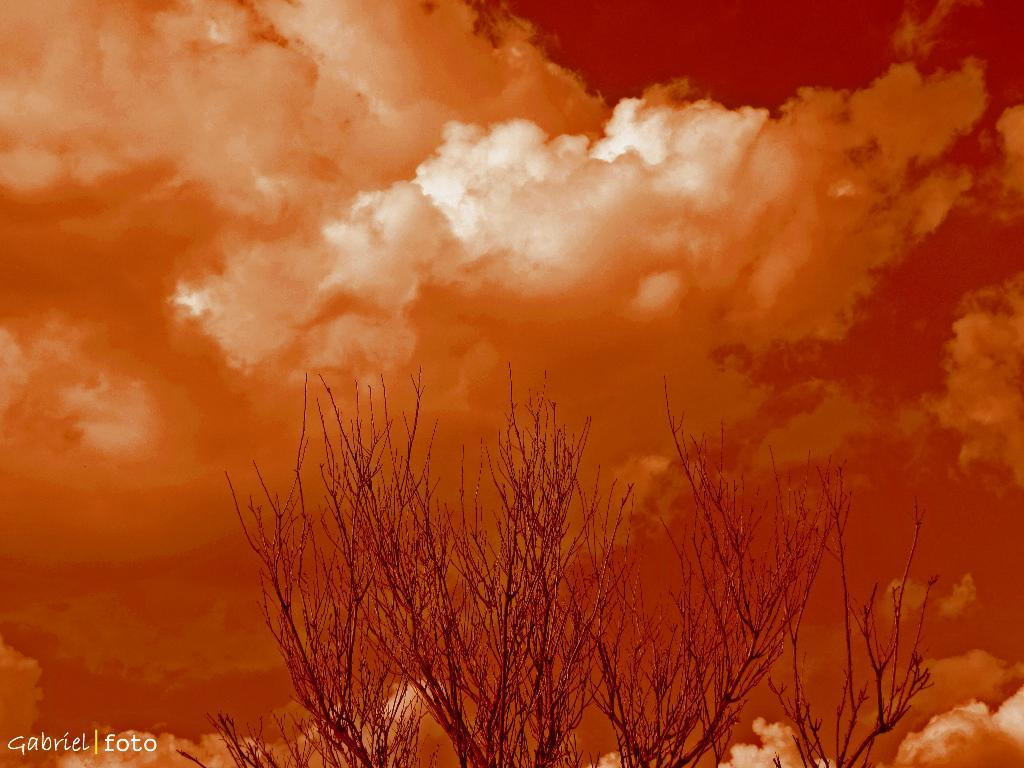What can be observed about the image's appearance? The image appears to be edited. What type of vegetation is present at the bottom of the image? There are trees at the bottom of the image. How would you describe the sky in the image? The sky is cloudy at the top of the image. Can you identify any additional elements on the image? There is a watermark on the left side of the image. How many bottles of wine can be seen on the island in the image? There is no island or wine bottles present in the image. What type of birds are flying in the sky in the image? There are no birds visible in the image; only clouds can be seen in the sky. 